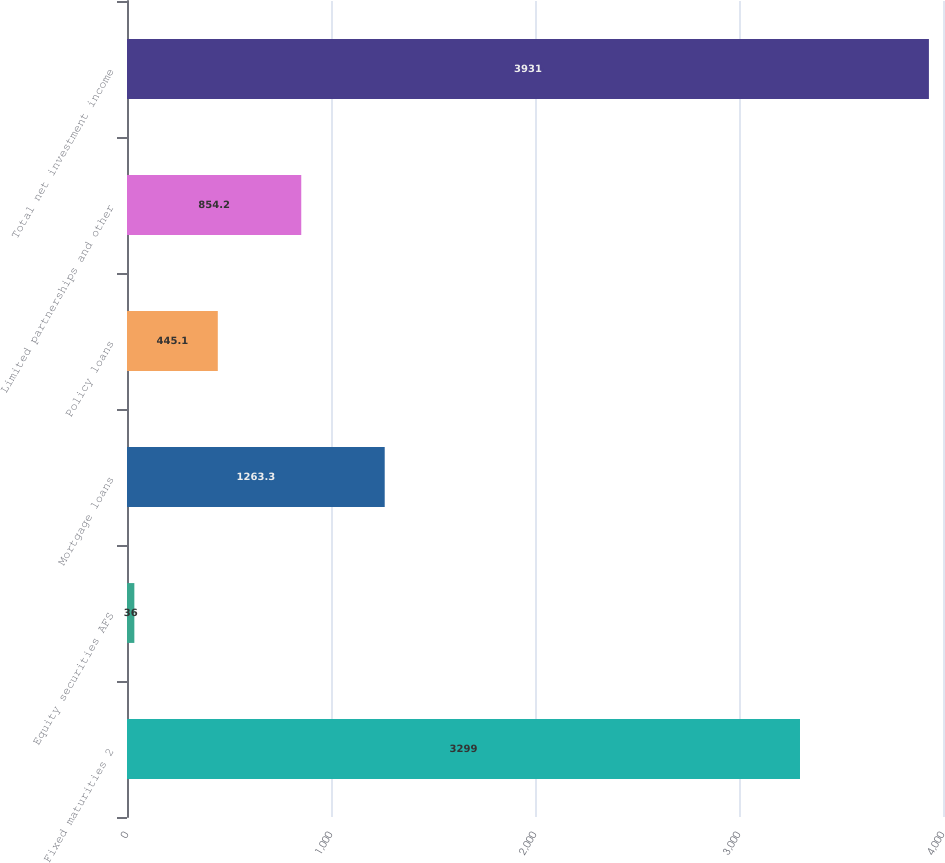<chart> <loc_0><loc_0><loc_500><loc_500><bar_chart><fcel>Fixed maturities 2<fcel>Equity securities AFS<fcel>Mortgage loans<fcel>Policy loans<fcel>Limited partnerships and other<fcel>Total net investment income<nl><fcel>3299<fcel>36<fcel>1263.3<fcel>445.1<fcel>854.2<fcel>3931<nl></chart> 